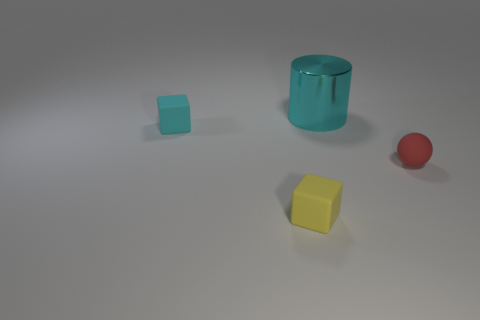Is there anything else that has the same size as the metallic thing?
Your response must be concise. No. Is the number of cyan shiny objects less than the number of big yellow rubber cubes?
Provide a succinct answer. No. There is a matte sphere; are there any tiny cyan rubber blocks to the left of it?
Keep it short and to the point. Yes. There is a rubber thing that is both on the left side of the tiny red matte ball and to the right of the small cyan object; what shape is it?
Provide a short and direct response. Cube. Are there any tiny yellow objects of the same shape as the red matte thing?
Provide a short and direct response. No. Do the cube that is behind the tiny yellow rubber block and the rubber thing on the right side of the large cyan shiny cylinder have the same size?
Offer a terse response. Yes. Is the number of large green cylinders greater than the number of objects?
Keep it short and to the point. No. How many cyan cubes have the same material as the big cyan object?
Offer a very short reply. 0. Is the large thing the same shape as the red matte thing?
Provide a succinct answer. No. There is a yellow cube in front of the small rubber block that is behind the small object in front of the tiny red object; what is its size?
Make the answer very short. Small. 